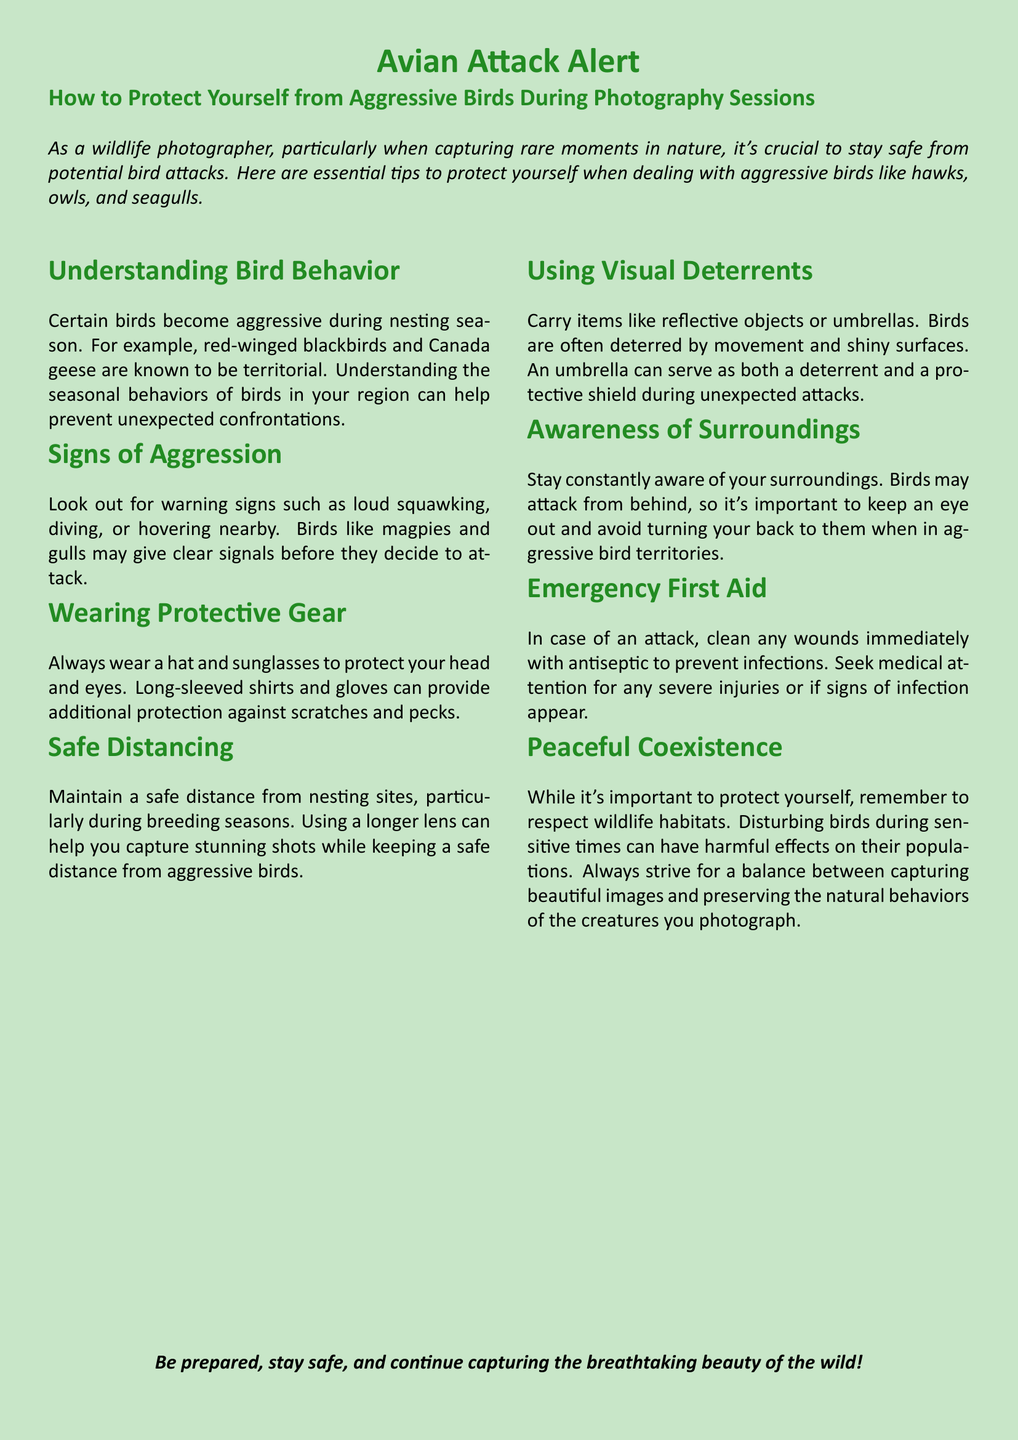What is the title of the document? The title of the document is the main heading that outlines the topic, which is presented prominently at the top.
Answer: Avian Attack Alert What type of birds are specifically mentioned as aggressive? The document lists certain species that are known for their aggressiveness, indicating focus areas for wildlife photographers.
Answer: Hawks, owls, and seagulls What should you wear to protect yourself? The document emphasizes the importance of protective clothing, highlighting specific items that should be worn.
Answer: Hat and sunglasses What is one sign of bird aggression listed in the document? The document provides specific behaviors to look out for, which indicate that a bird may be preparing to attack.
Answer: Loud squawking What should you carry to deter birds? The document suggests a particular type of item designed to keep aggressive birds at bay, enhancing personal safety.
Answer: Reflective objects or umbrellas What should you do in case of an attack? The document outlines the initial response to a bird attack, which is crucial for injury management.
Answer: Clean any wounds immediately During what season should you maintain a safe distance from nesting sites? The document indicates specific periods when birds may be more territorial, necessitating precautions for safety.
Answer: Breeding season Why is it important to respect wildlife habitats? The document addresses the broader implications of wildlife photography on bird populations, signifying ethical considerations.
Answer: Harmful effects on their populations 